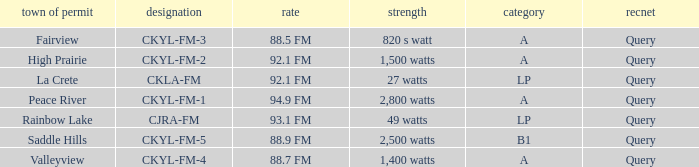What is the city of license that has a 1,400 watts power Valleyview. 